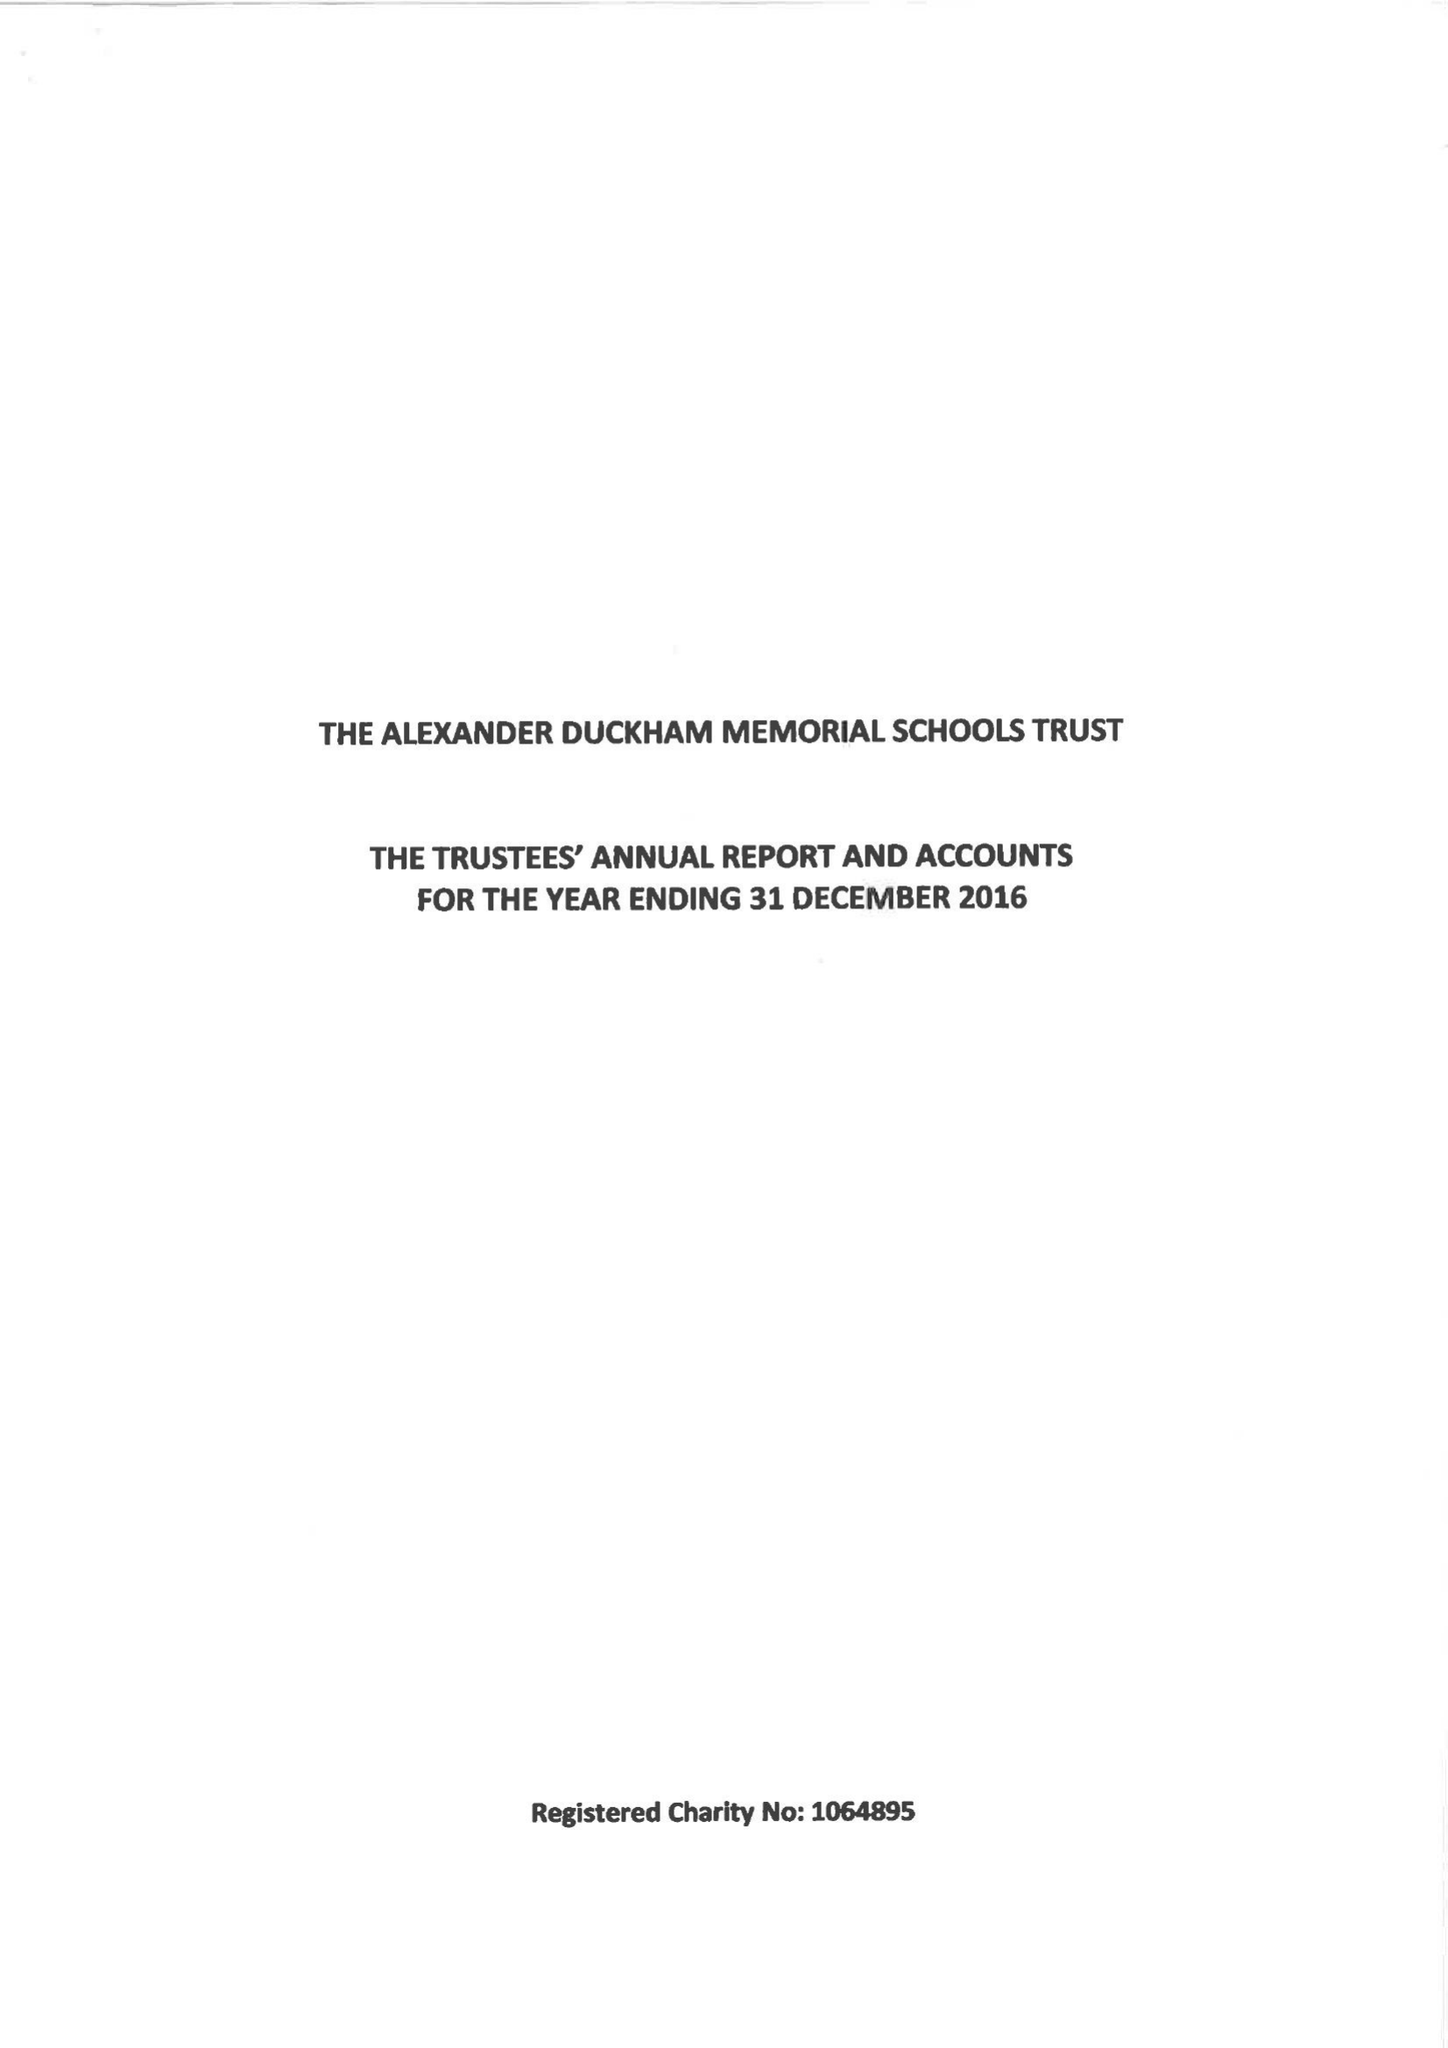What is the value for the charity_number?
Answer the question using a single word or phrase. 1064895 